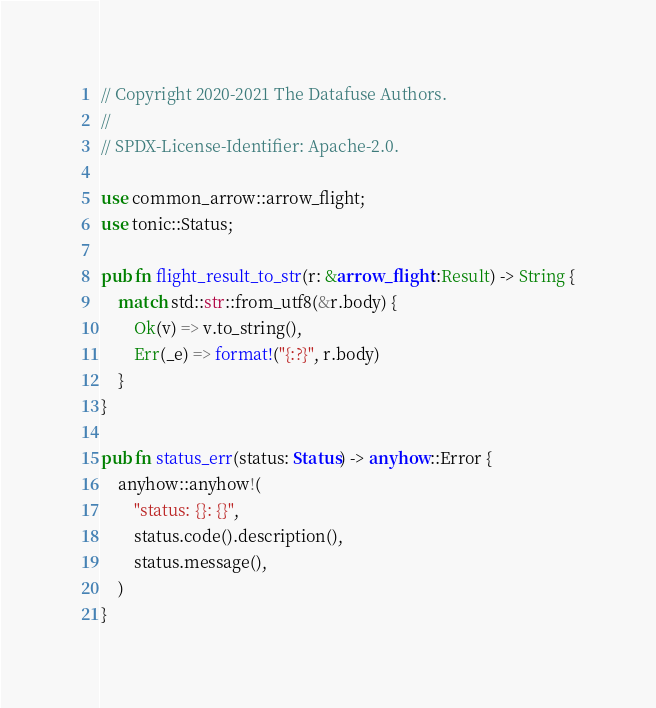Convert code to text. <code><loc_0><loc_0><loc_500><loc_500><_Rust_>// Copyright 2020-2021 The Datafuse Authors.
//
// SPDX-License-Identifier: Apache-2.0.

use common_arrow::arrow_flight;
use tonic::Status;

pub fn flight_result_to_str(r: &arrow_flight::Result) -> String {
    match std::str::from_utf8(&r.body) {
        Ok(v) => v.to_string(),
        Err(_e) => format!("{:?}", r.body)
    }
}

pub fn status_err(status: Status) -> anyhow::Error {
    anyhow::anyhow!(
        "status: {}: {}",
        status.code().description(),
        status.message(),
    )
}
</code> 